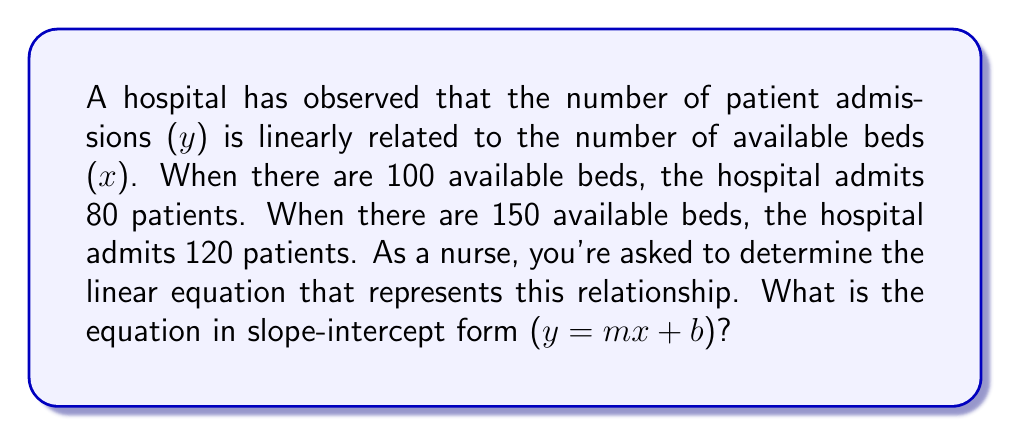Can you answer this question? To find the linear equation, we'll follow these steps:

1. Calculate the slope (m):
   $m = \frac{y_2 - y_1}{x_2 - x_1} = \frac{120 - 80}{150 - 100} = \frac{40}{50} = 0.8$

2. Use the point-slope form of a line:
   $y - y_1 = m(x - x_1)$
   Let's use the first point (100, 80):
   $y - 80 = 0.8(x - 100)$

3. Expand the equation:
   $y - 80 = 0.8x - 80$

4. Solve for y to get the slope-intercept form:
   $y = 0.8x - 80 + 80$
   $y = 0.8x$

Therefore, the equation in slope-intercept form is $y = 0.8x$.

5. Interpret the result:
   - The slope (0.8) indicates that for every additional available bed, the hospital admits 0.8 more patients on average.
   - The y-intercept is 0, which means when there are no available beds (x = 0), no patients are admitted (y = 0).

This linear relationship helps nurses and hospital staff predict admission rates based on bed availability, which is crucial for resource allocation and patient care planning.
Answer: $y = 0.8x$ 